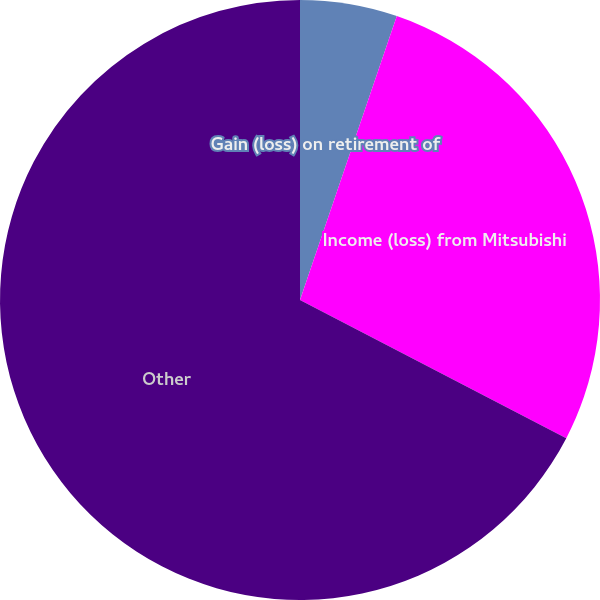Convert chart. <chart><loc_0><loc_0><loc_500><loc_500><pie_chart><fcel>Gain (loss) on retirement of<fcel>Income (loss) from Mitsubishi<fcel>Other<nl><fcel>5.23%<fcel>27.39%<fcel>67.39%<nl></chart> 